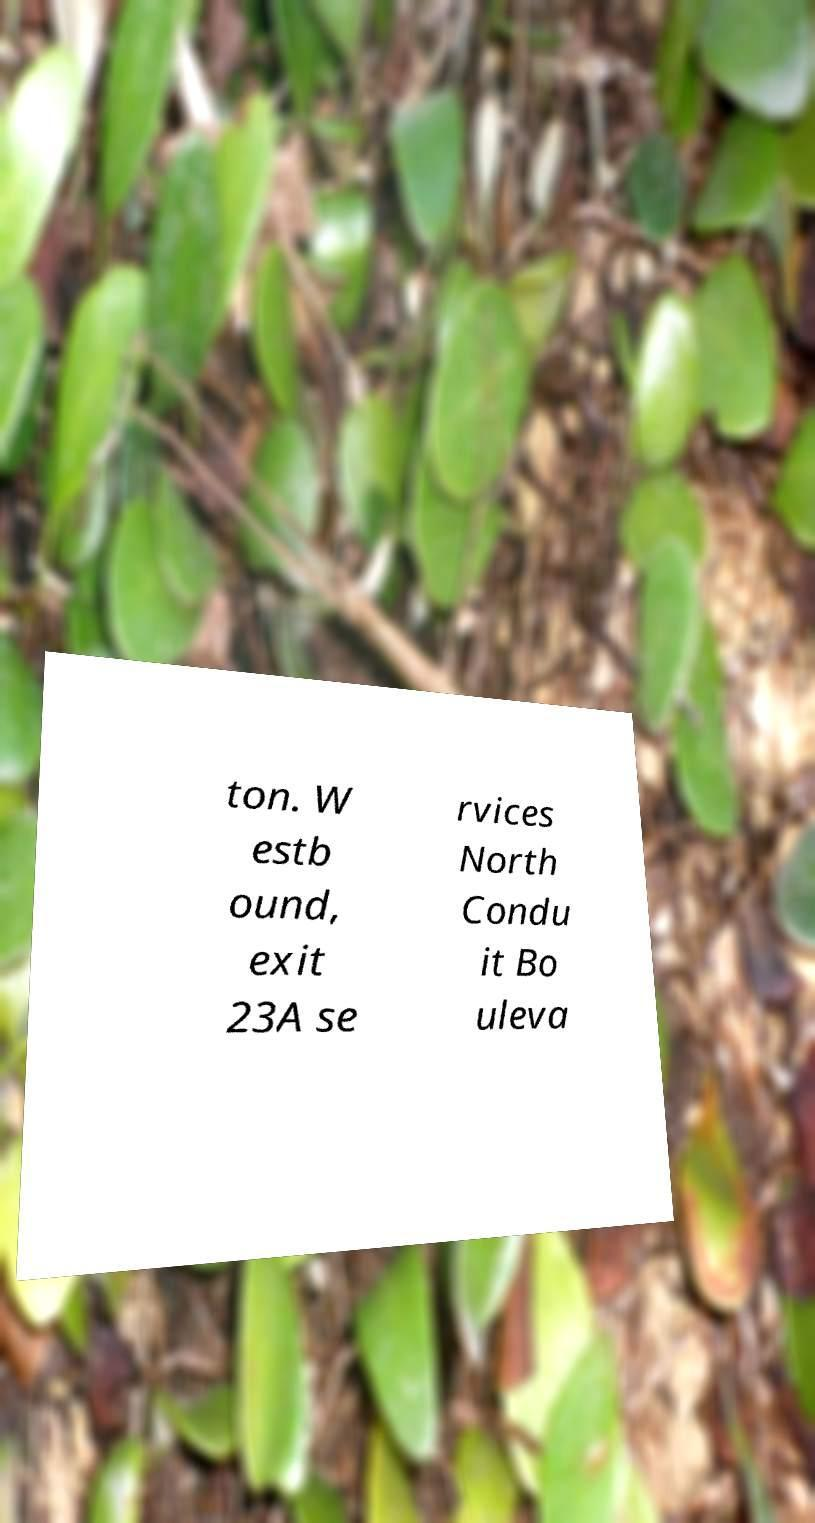For documentation purposes, I need the text within this image transcribed. Could you provide that? ton. W estb ound, exit 23A se rvices North Condu it Bo uleva 